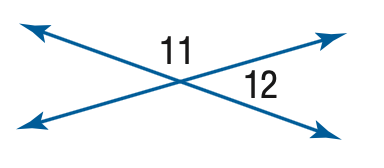Answer the mathemtical geometry problem and directly provide the correct option letter.
Question: m \angle 11 = 4 x, m \angle 12 = 2 x - 6. Find the measure of \angle 11.
Choices: A: 116 B: 118 C: 120 D: 124 D 